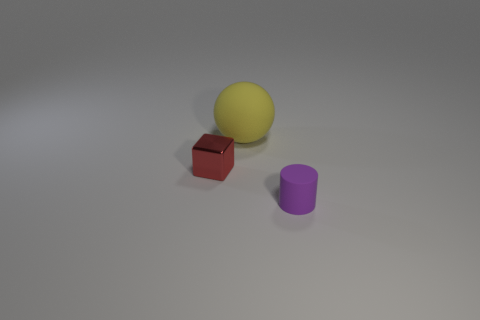Is the number of red metallic things that are in front of the tiny red metallic cube less than the number of red metal cubes?
Your response must be concise. Yes. There is a small object that is behind the matte thing that is to the right of the big yellow matte thing; are there any rubber spheres on the right side of it?
Keep it short and to the point. Yes. Is the material of the block the same as the thing that is in front of the tiny red metallic block?
Provide a succinct answer. No. What color is the object on the right side of the rubber thing that is behind the tiny purple matte thing?
Give a very brief answer. Purple. What size is the matte object to the left of the small object that is in front of the thing that is on the left side of the big rubber ball?
Your response must be concise. Large. How many other things are the same size as the metal thing?
Give a very brief answer. 1. How big is the rubber thing that is to the left of the cylinder?
Your answer should be very brief. Large. How many large spheres have the same material as the tiny red block?
Your response must be concise. 0. What shape is the matte object in front of the red shiny object?
Keep it short and to the point. Cylinder. What is the material of the yellow thing?
Provide a short and direct response. Rubber. 